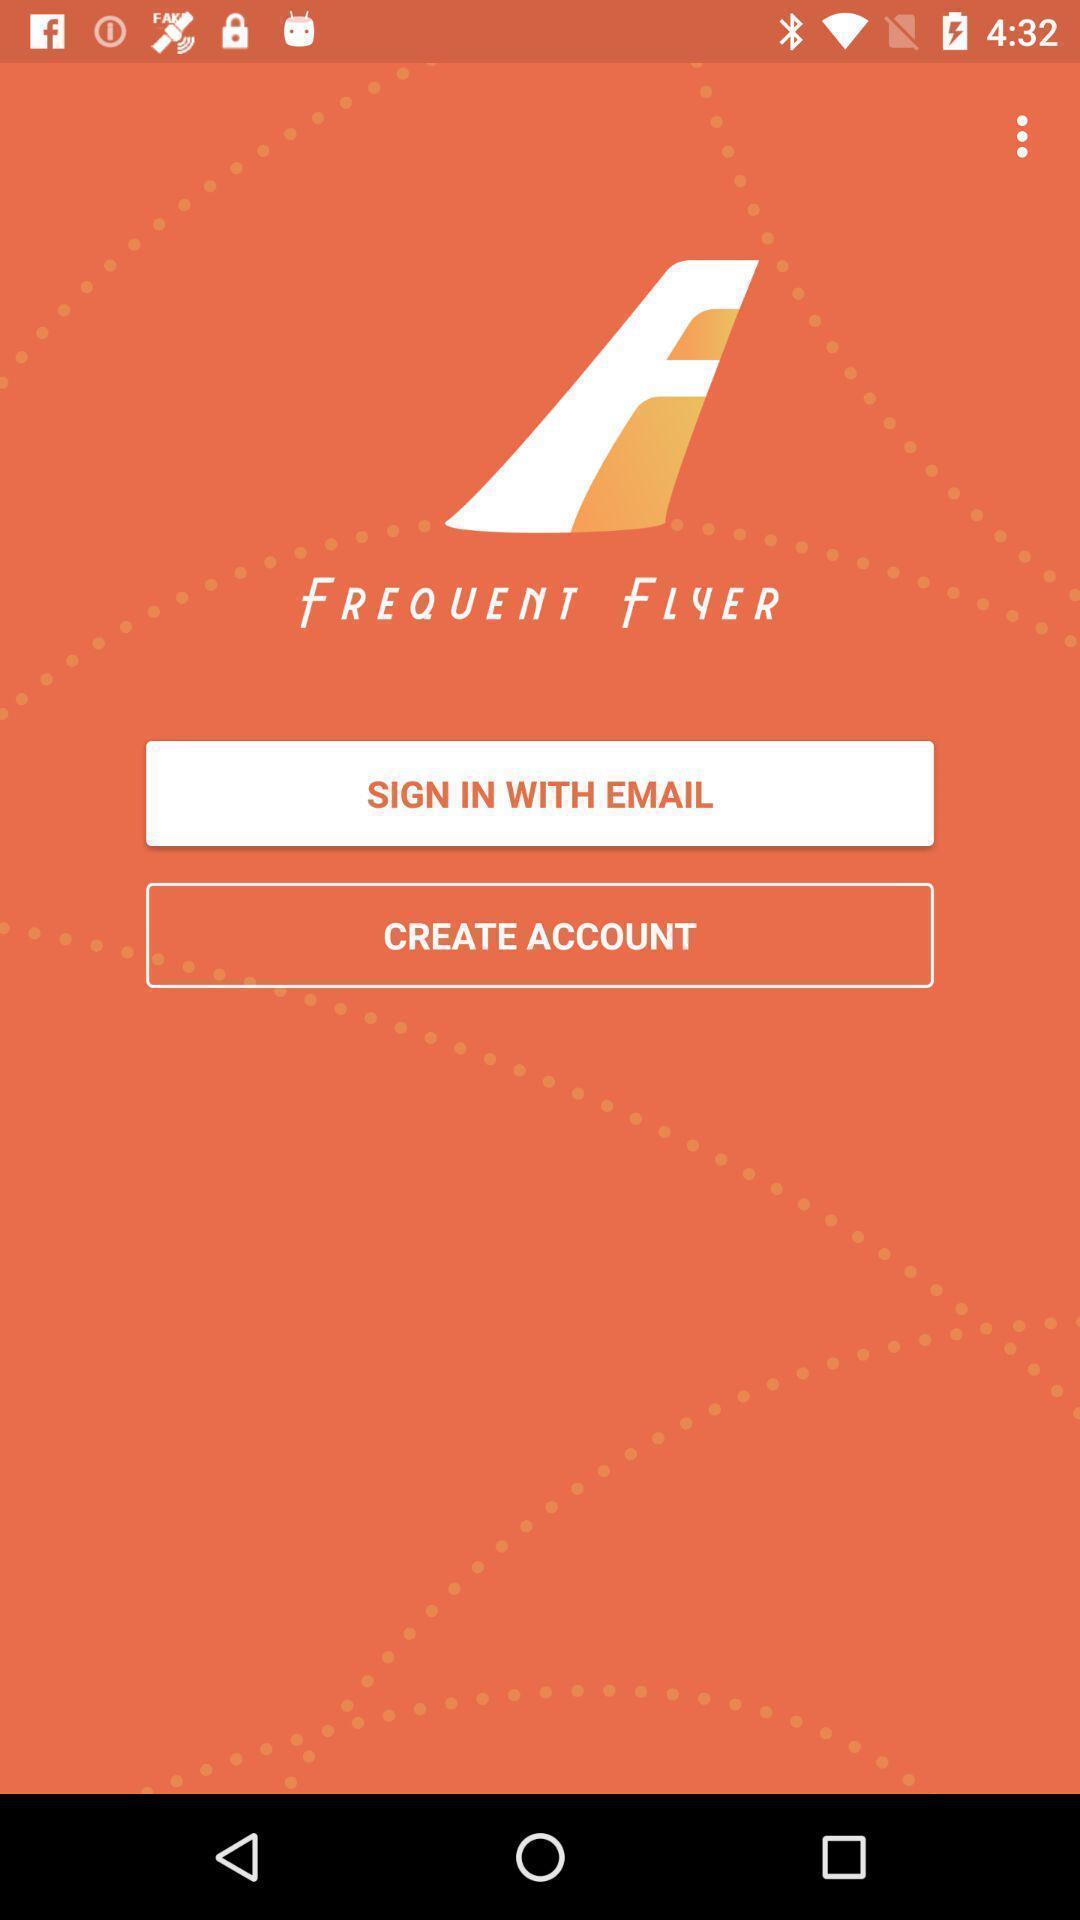What can you discern from this picture? Welcome page of the app. 